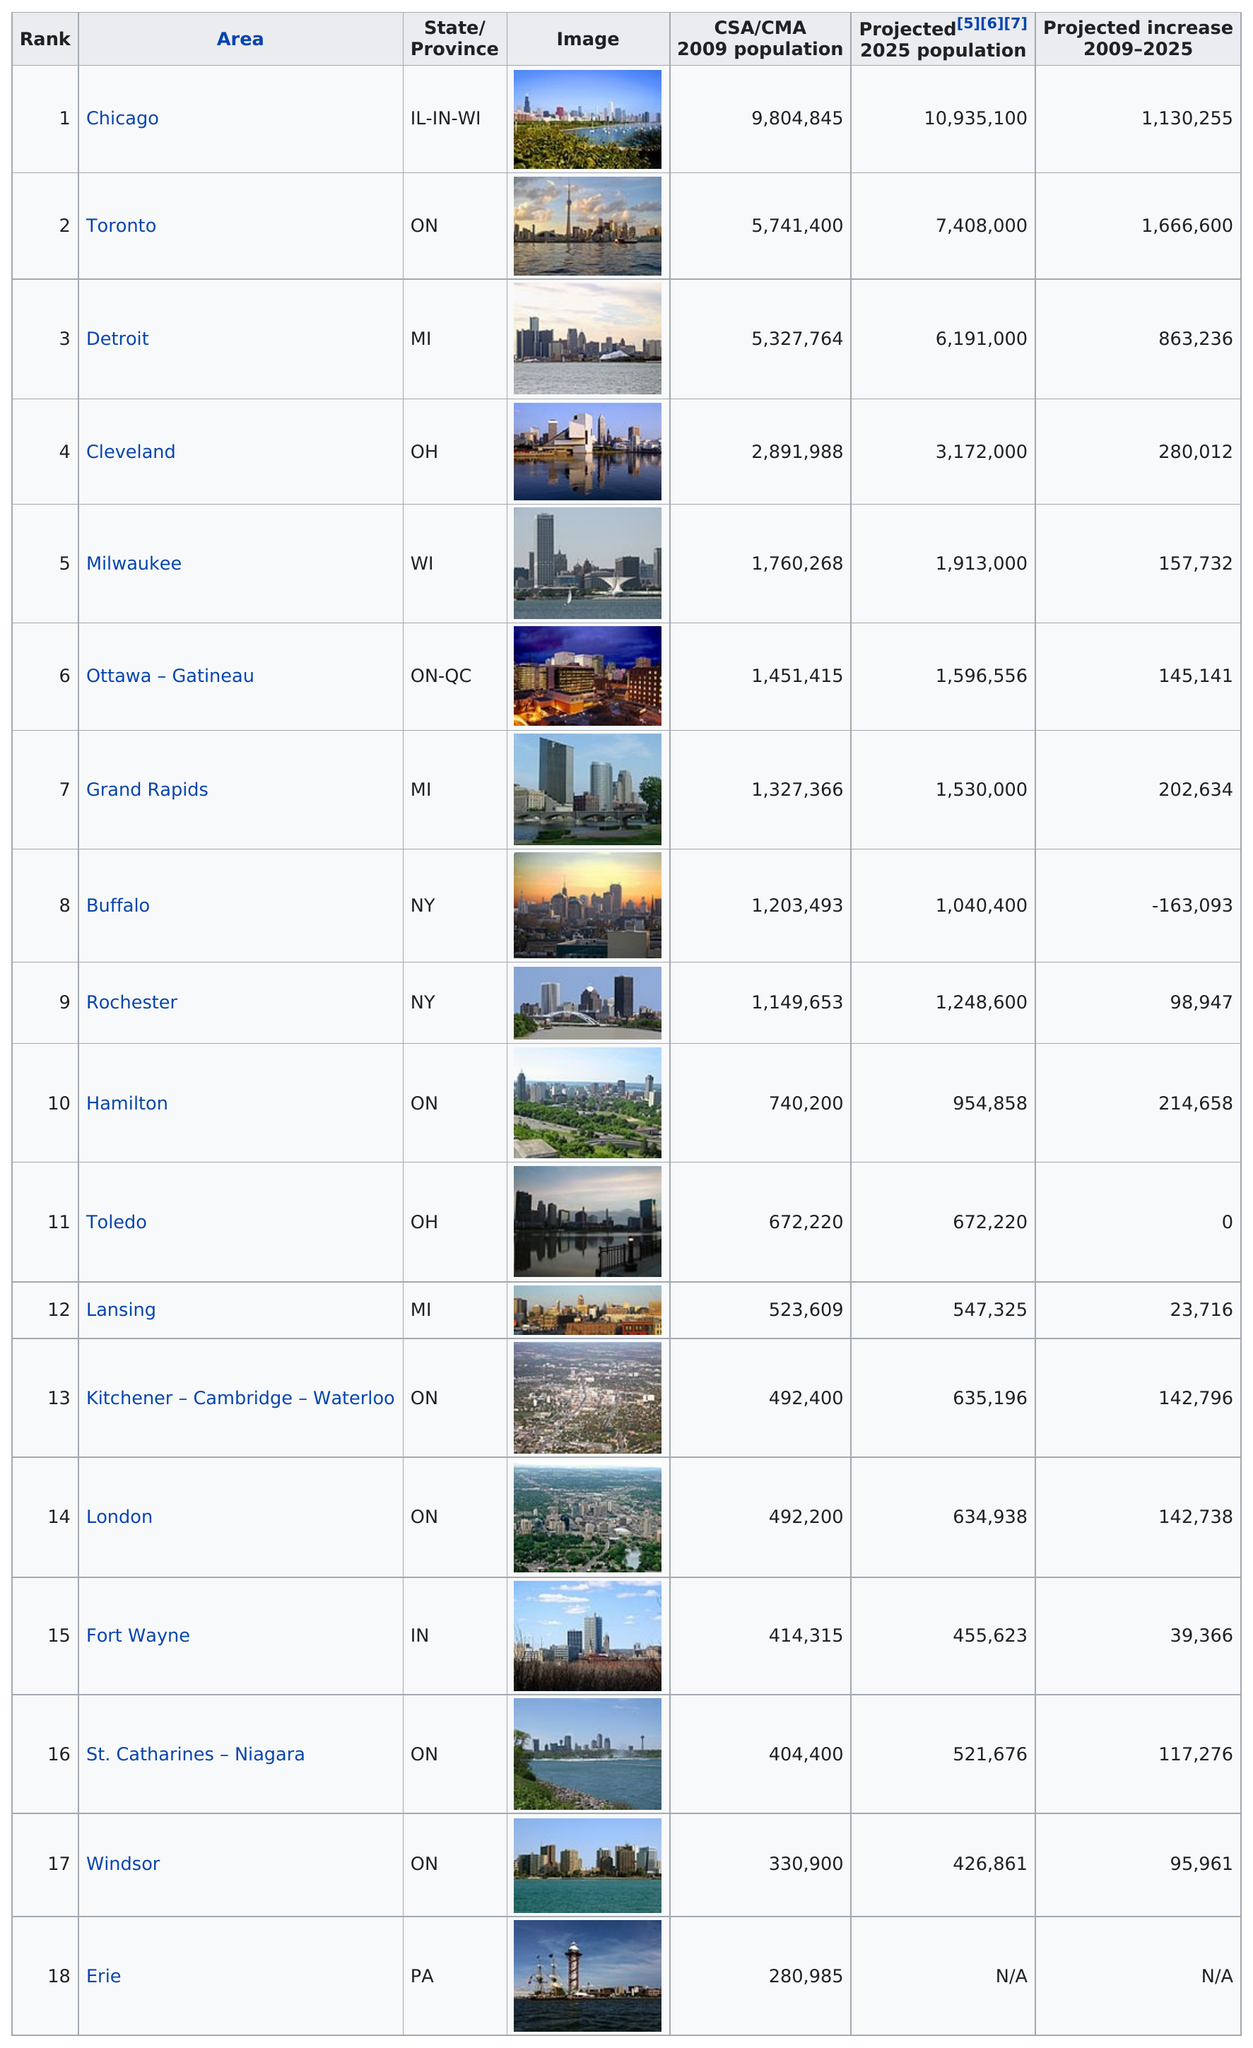Specify some key components in this picture. By 2025, Toledo's population is projected to reach 672,220. Chicago ranks just before Toronto in projected population growth, making it a significant population center in the near future. Toronto's population is expected to grow at a higher rate compared to Hamilton's population in the near future. Grand Rapids is the largest population center in Michigan after Detroit. There are seven population centers located in both the United States and Canada that are part of the Great Lakes region. 